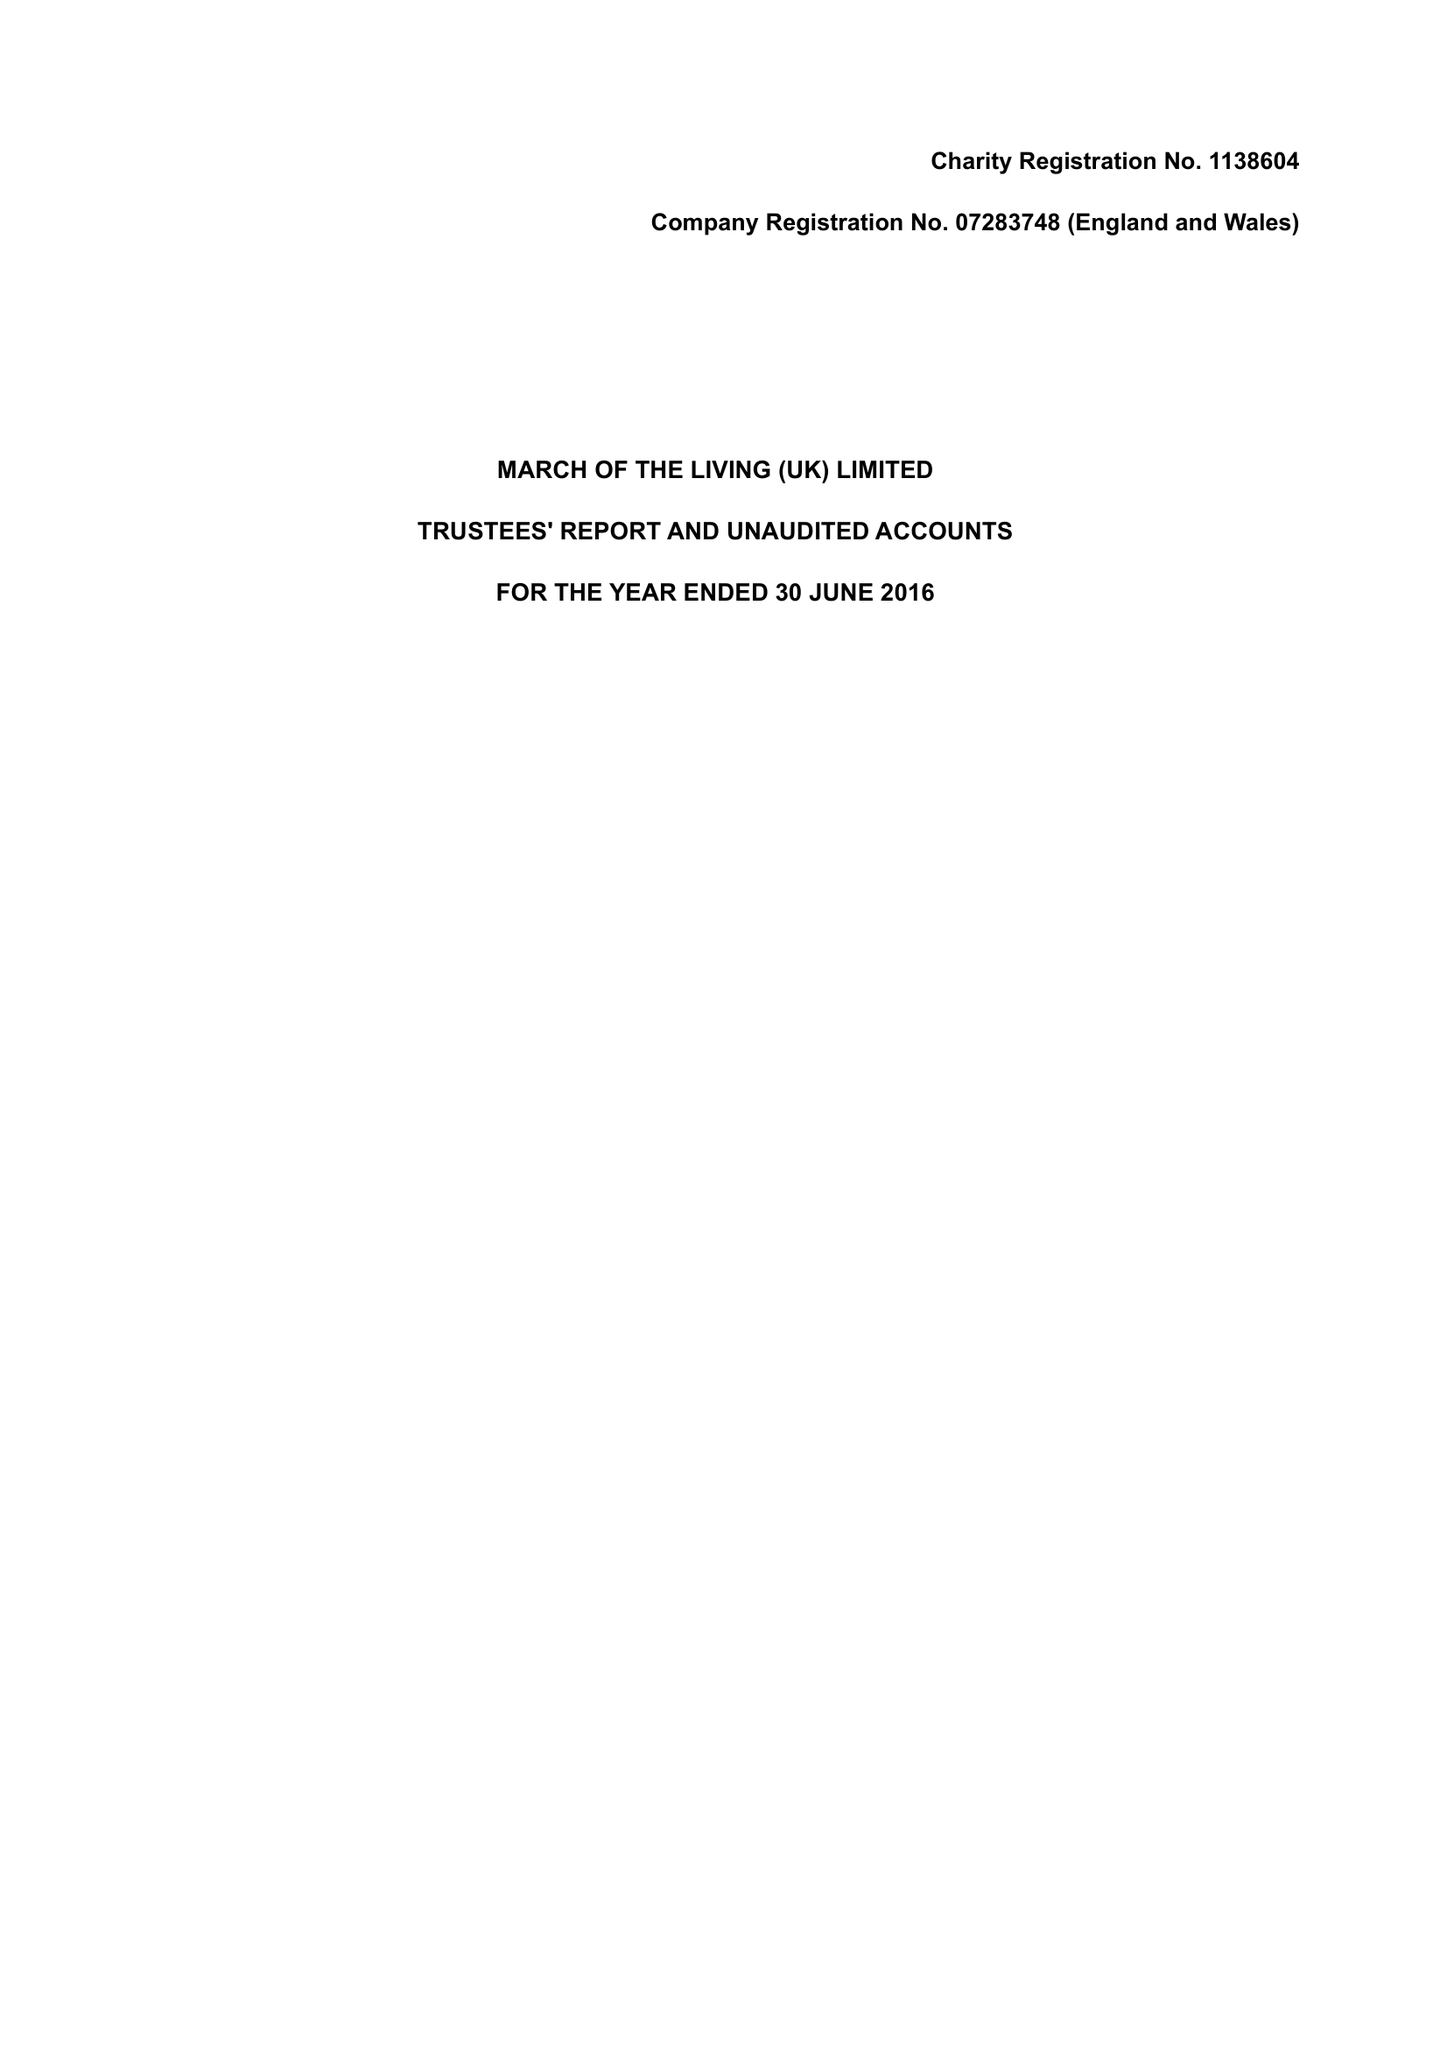What is the value for the charity_name?
Answer the question using a single word or phrase. March Of The Living (Uk) Ltd. 